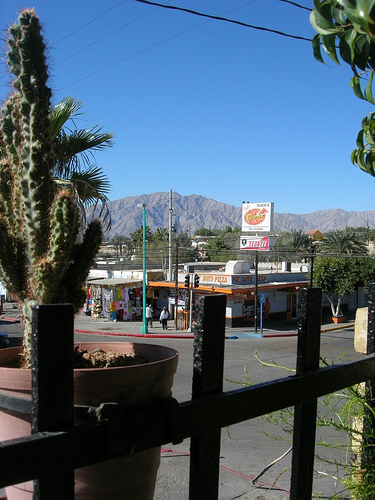Identify the text displayed in this image. PIZZA 